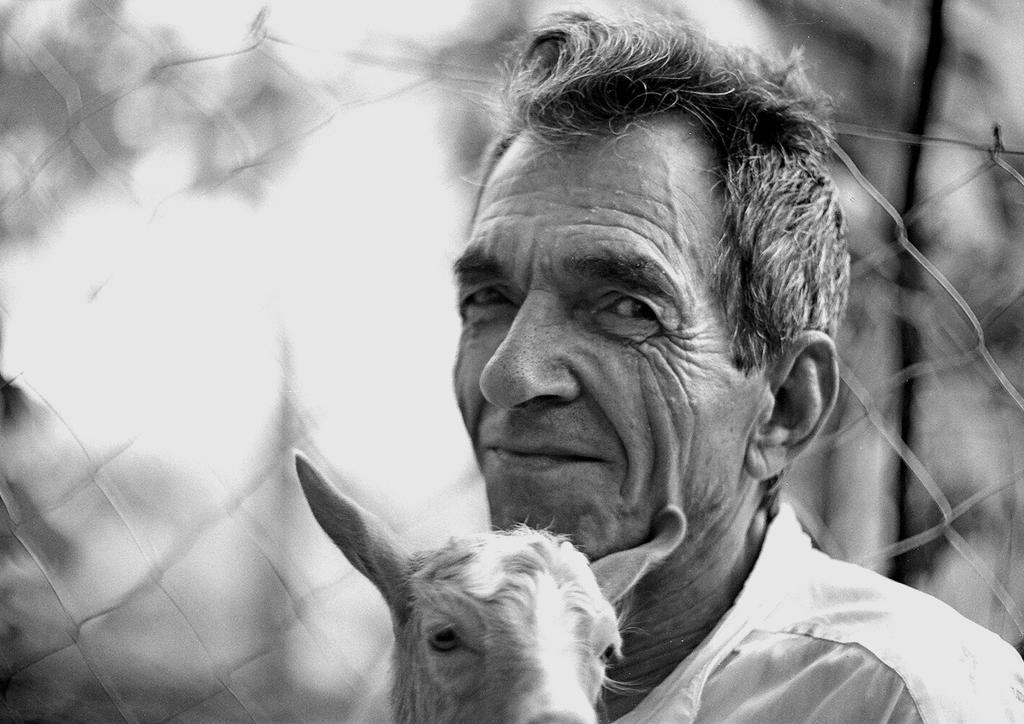How would you summarize this image in a sentence or two? In this picture there is a man and we can see an animal. In the background of the image it is blurry and we can see mesh. 